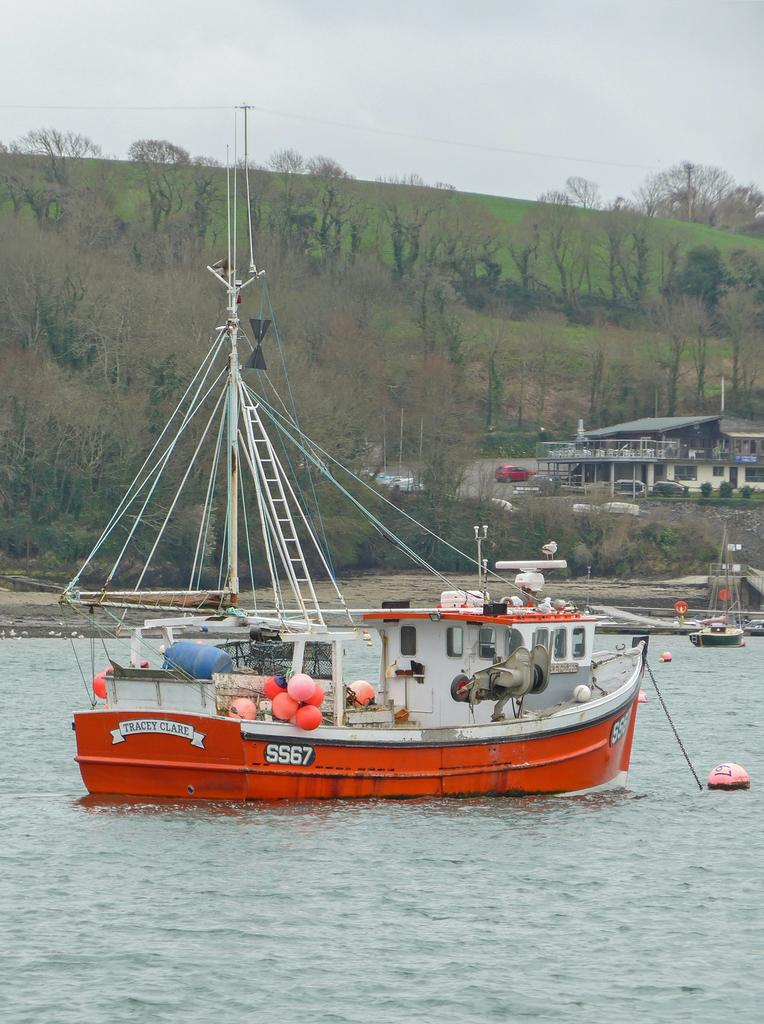What type of transportation can be seen in the image? There are boats and vehicles in the image. What structures are present in the image? There are houses in the image. What natural elements can be seen in the image? There are trees and water visible in the image. What man-made objects are present in the image? There are poles in the image. What is the color of the sky in the image? The sky is in white and blue color. Where is the bed located in the image? There is no bed present in the image. What type of bomb can be seen in the image? There is no bomb present in the image. 